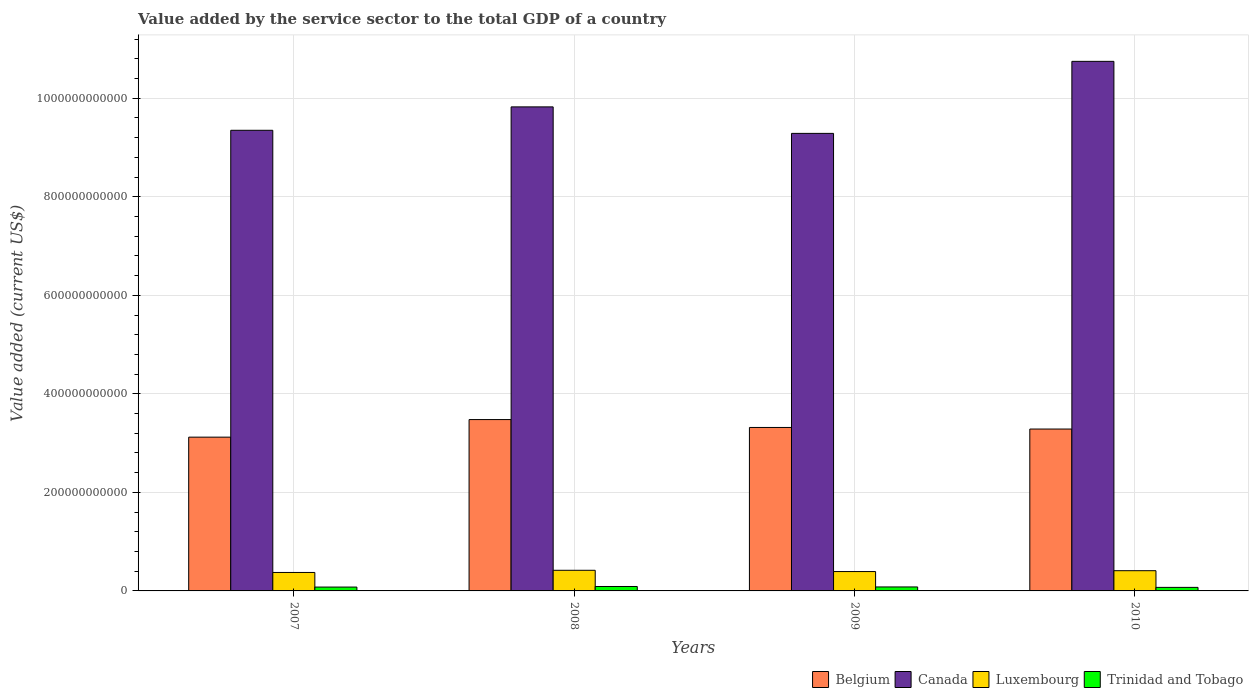How many groups of bars are there?
Your response must be concise. 4. Are the number of bars per tick equal to the number of legend labels?
Your response must be concise. Yes. Are the number of bars on each tick of the X-axis equal?
Give a very brief answer. Yes. In how many cases, is the number of bars for a given year not equal to the number of legend labels?
Make the answer very short. 0. What is the value added by the service sector to the total GDP in Belgium in 2009?
Provide a succinct answer. 3.32e+11. Across all years, what is the maximum value added by the service sector to the total GDP in Trinidad and Tobago?
Offer a terse response. 8.99e+09. Across all years, what is the minimum value added by the service sector to the total GDP in Belgium?
Offer a terse response. 3.12e+11. What is the total value added by the service sector to the total GDP in Canada in the graph?
Provide a short and direct response. 3.92e+12. What is the difference between the value added by the service sector to the total GDP in Belgium in 2007 and that in 2009?
Your answer should be very brief. -1.97e+1. What is the difference between the value added by the service sector to the total GDP in Belgium in 2008 and the value added by the service sector to the total GDP in Trinidad and Tobago in 2010?
Ensure brevity in your answer.  3.41e+11. What is the average value added by the service sector to the total GDP in Luxembourg per year?
Ensure brevity in your answer.  3.99e+1. In the year 2010, what is the difference between the value added by the service sector to the total GDP in Canada and value added by the service sector to the total GDP in Trinidad and Tobago?
Provide a short and direct response. 1.07e+12. In how many years, is the value added by the service sector to the total GDP in Luxembourg greater than 800000000000 US$?
Your response must be concise. 0. What is the ratio of the value added by the service sector to the total GDP in Belgium in 2008 to that in 2009?
Offer a very short reply. 1.05. Is the value added by the service sector to the total GDP in Trinidad and Tobago in 2007 less than that in 2008?
Your response must be concise. Yes. Is the difference between the value added by the service sector to the total GDP in Canada in 2007 and 2010 greater than the difference between the value added by the service sector to the total GDP in Trinidad and Tobago in 2007 and 2010?
Your answer should be compact. No. What is the difference between the highest and the second highest value added by the service sector to the total GDP in Luxembourg?
Your answer should be very brief. 8.35e+08. What is the difference between the highest and the lowest value added by the service sector to the total GDP in Trinidad and Tobago?
Keep it short and to the point. 1.80e+09. Is it the case that in every year, the sum of the value added by the service sector to the total GDP in Luxembourg and value added by the service sector to the total GDP in Trinidad and Tobago is greater than the sum of value added by the service sector to the total GDP in Canada and value added by the service sector to the total GDP in Belgium?
Give a very brief answer. Yes. What does the 1st bar from the left in 2008 represents?
Keep it short and to the point. Belgium. What does the 1st bar from the right in 2008 represents?
Offer a terse response. Trinidad and Tobago. How many years are there in the graph?
Offer a terse response. 4. What is the difference between two consecutive major ticks on the Y-axis?
Keep it short and to the point. 2.00e+11. Does the graph contain any zero values?
Ensure brevity in your answer.  No. Does the graph contain grids?
Ensure brevity in your answer.  Yes. Where does the legend appear in the graph?
Keep it short and to the point. Bottom right. How many legend labels are there?
Offer a terse response. 4. How are the legend labels stacked?
Ensure brevity in your answer.  Horizontal. What is the title of the graph?
Keep it short and to the point. Value added by the service sector to the total GDP of a country. Does "Central Europe" appear as one of the legend labels in the graph?
Offer a terse response. No. What is the label or title of the Y-axis?
Your response must be concise. Value added (current US$). What is the Value added (current US$) in Belgium in 2007?
Keep it short and to the point. 3.12e+11. What is the Value added (current US$) in Canada in 2007?
Offer a very short reply. 9.35e+11. What is the Value added (current US$) of Luxembourg in 2007?
Provide a short and direct response. 3.75e+1. What is the Value added (current US$) in Trinidad and Tobago in 2007?
Give a very brief answer. 7.81e+09. What is the Value added (current US$) in Belgium in 2008?
Give a very brief answer. 3.48e+11. What is the Value added (current US$) of Canada in 2008?
Keep it short and to the point. 9.82e+11. What is the Value added (current US$) in Luxembourg in 2008?
Your answer should be very brief. 4.19e+1. What is the Value added (current US$) in Trinidad and Tobago in 2008?
Provide a succinct answer. 8.99e+09. What is the Value added (current US$) of Belgium in 2009?
Offer a terse response. 3.32e+11. What is the Value added (current US$) of Canada in 2009?
Keep it short and to the point. 9.29e+11. What is the Value added (current US$) in Luxembourg in 2009?
Offer a very short reply. 3.93e+1. What is the Value added (current US$) of Trinidad and Tobago in 2009?
Make the answer very short. 8.06e+09. What is the Value added (current US$) of Belgium in 2010?
Make the answer very short. 3.29e+11. What is the Value added (current US$) of Canada in 2010?
Your answer should be very brief. 1.07e+12. What is the Value added (current US$) of Luxembourg in 2010?
Your answer should be compact. 4.10e+1. What is the Value added (current US$) of Trinidad and Tobago in 2010?
Keep it short and to the point. 7.19e+09. Across all years, what is the maximum Value added (current US$) of Belgium?
Your response must be concise. 3.48e+11. Across all years, what is the maximum Value added (current US$) in Canada?
Provide a succinct answer. 1.07e+12. Across all years, what is the maximum Value added (current US$) in Luxembourg?
Offer a very short reply. 4.19e+1. Across all years, what is the maximum Value added (current US$) in Trinidad and Tobago?
Give a very brief answer. 8.99e+09. Across all years, what is the minimum Value added (current US$) in Belgium?
Your response must be concise. 3.12e+11. Across all years, what is the minimum Value added (current US$) in Canada?
Provide a succinct answer. 9.29e+11. Across all years, what is the minimum Value added (current US$) in Luxembourg?
Make the answer very short. 3.75e+1. Across all years, what is the minimum Value added (current US$) in Trinidad and Tobago?
Provide a succinct answer. 7.19e+09. What is the total Value added (current US$) of Belgium in the graph?
Your answer should be compact. 1.32e+12. What is the total Value added (current US$) of Canada in the graph?
Keep it short and to the point. 3.92e+12. What is the total Value added (current US$) in Luxembourg in the graph?
Your answer should be compact. 1.60e+11. What is the total Value added (current US$) in Trinidad and Tobago in the graph?
Your answer should be very brief. 3.21e+1. What is the difference between the Value added (current US$) of Belgium in 2007 and that in 2008?
Provide a short and direct response. -3.57e+1. What is the difference between the Value added (current US$) in Canada in 2007 and that in 2008?
Offer a very short reply. -4.75e+1. What is the difference between the Value added (current US$) in Luxembourg in 2007 and that in 2008?
Your response must be concise. -4.41e+09. What is the difference between the Value added (current US$) of Trinidad and Tobago in 2007 and that in 2008?
Make the answer very short. -1.19e+09. What is the difference between the Value added (current US$) of Belgium in 2007 and that in 2009?
Your response must be concise. -1.97e+1. What is the difference between the Value added (current US$) in Canada in 2007 and that in 2009?
Your response must be concise. 6.28e+09. What is the difference between the Value added (current US$) in Luxembourg in 2007 and that in 2009?
Ensure brevity in your answer.  -1.84e+09. What is the difference between the Value added (current US$) of Trinidad and Tobago in 2007 and that in 2009?
Make the answer very short. -2.50e+08. What is the difference between the Value added (current US$) of Belgium in 2007 and that in 2010?
Provide a short and direct response. -1.65e+1. What is the difference between the Value added (current US$) of Canada in 2007 and that in 2010?
Ensure brevity in your answer.  -1.40e+11. What is the difference between the Value added (current US$) in Luxembourg in 2007 and that in 2010?
Make the answer very short. -3.57e+09. What is the difference between the Value added (current US$) in Trinidad and Tobago in 2007 and that in 2010?
Offer a terse response. 6.19e+08. What is the difference between the Value added (current US$) of Belgium in 2008 and that in 2009?
Provide a succinct answer. 1.60e+1. What is the difference between the Value added (current US$) in Canada in 2008 and that in 2009?
Provide a short and direct response. 5.38e+1. What is the difference between the Value added (current US$) of Luxembourg in 2008 and that in 2009?
Make the answer very short. 2.56e+09. What is the difference between the Value added (current US$) in Trinidad and Tobago in 2008 and that in 2009?
Your response must be concise. 9.36e+08. What is the difference between the Value added (current US$) of Belgium in 2008 and that in 2010?
Ensure brevity in your answer.  1.92e+1. What is the difference between the Value added (current US$) in Canada in 2008 and that in 2010?
Ensure brevity in your answer.  -9.24e+1. What is the difference between the Value added (current US$) of Luxembourg in 2008 and that in 2010?
Keep it short and to the point. 8.35e+08. What is the difference between the Value added (current US$) in Trinidad and Tobago in 2008 and that in 2010?
Offer a very short reply. 1.80e+09. What is the difference between the Value added (current US$) of Belgium in 2009 and that in 2010?
Your answer should be compact. 3.19e+09. What is the difference between the Value added (current US$) of Canada in 2009 and that in 2010?
Keep it short and to the point. -1.46e+11. What is the difference between the Value added (current US$) of Luxembourg in 2009 and that in 2010?
Make the answer very short. -1.73e+09. What is the difference between the Value added (current US$) of Trinidad and Tobago in 2009 and that in 2010?
Keep it short and to the point. 8.68e+08. What is the difference between the Value added (current US$) of Belgium in 2007 and the Value added (current US$) of Canada in 2008?
Offer a very short reply. -6.70e+11. What is the difference between the Value added (current US$) in Belgium in 2007 and the Value added (current US$) in Luxembourg in 2008?
Give a very brief answer. 2.70e+11. What is the difference between the Value added (current US$) of Belgium in 2007 and the Value added (current US$) of Trinidad and Tobago in 2008?
Make the answer very short. 3.03e+11. What is the difference between the Value added (current US$) of Canada in 2007 and the Value added (current US$) of Luxembourg in 2008?
Keep it short and to the point. 8.93e+11. What is the difference between the Value added (current US$) of Canada in 2007 and the Value added (current US$) of Trinidad and Tobago in 2008?
Your response must be concise. 9.26e+11. What is the difference between the Value added (current US$) in Luxembourg in 2007 and the Value added (current US$) in Trinidad and Tobago in 2008?
Your response must be concise. 2.85e+1. What is the difference between the Value added (current US$) in Belgium in 2007 and the Value added (current US$) in Canada in 2009?
Offer a very short reply. -6.17e+11. What is the difference between the Value added (current US$) in Belgium in 2007 and the Value added (current US$) in Luxembourg in 2009?
Offer a terse response. 2.73e+11. What is the difference between the Value added (current US$) in Belgium in 2007 and the Value added (current US$) in Trinidad and Tobago in 2009?
Keep it short and to the point. 3.04e+11. What is the difference between the Value added (current US$) of Canada in 2007 and the Value added (current US$) of Luxembourg in 2009?
Your response must be concise. 8.96e+11. What is the difference between the Value added (current US$) in Canada in 2007 and the Value added (current US$) in Trinidad and Tobago in 2009?
Offer a terse response. 9.27e+11. What is the difference between the Value added (current US$) in Luxembourg in 2007 and the Value added (current US$) in Trinidad and Tobago in 2009?
Provide a succinct answer. 2.94e+1. What is the difference between the Value added (current US$) of Belgium in 2007 and the Value added (current US$) of Canada in 2010?
Offer a terse response. -7.63e+11. What is the difference between the Value added (current US$) of Belgium in 2007 and the Value added (current US$) of Luxembourg in 2010?
Your answer should be very brief. 2.71e+11. What is the difference between the Value added (current US$) of Belgium in 2007 and the Value added (current US$) of Trinidad and Tobago in 2010?
Offer a very short reply. 3.05e+11. What is the difference between the Value added (current US$) in Canada in 2007 and the Value added (current US$) in Luxembourg in 2010?
Provide a succinct answer. 8.94e+11. What is the difference between the Value added (current US$) of Canada in 2007 and the Value added (current US$) of Trinidad and Tobago in 2010?
Your answer should be very brief. 9.28e+11. What is the difference between the Value added (current US$) of Luxembourg in 2007 and the Value added (current US$) of Trinidad and Tobago in 2010?
Ensure brevity in your answer.  3.03e+1. What is the difference between the Value added (current US$) of Belgium in 2008 and the Value added (current US$) of Canada in 2009?
Your answer should be very brief. -5.81e+11. What is the difference between the Value added (current US$) in Belgium in 2008 and the Value added (current US$) in Luxembourg in 2009?
Your answer should be compact. 3.08e+11. What is the difference between the Value added (current US$) in Belgium in 2008 and the Value added (current US$) in Trinidad and Tobago in 2009?
Make the answer very short. 3.40e+11. What is the difference between the Value added (current US$) in Canada in 2008 and the Value added (current US$) in Luxembourg in 2009?
Your response must be concise. 9.43e+11. What is the difference between the Value added (current US$) of Canada in 2008 and the Value added (current US$) of Trinidad and Tobago in 2009?
Offer a terse response. 9.74e+11. What is the difference between the Value added (current US$) of Luxembourg in 2008 and the Value added (current US$) of Trinidad and Tobago in 2009?
Offer a terse response. 3.38e+1. What is the difference between the Value added (current US$) in Belgium in 2008 and the Value added (current US$) in Canada in 2010?
Give a very brief answer. -7.27e+11. What is the difference between the Value added (current US$) in Belgium in 2008 and the Value added (current US$) in Luxembourg in 2010?
Your answer should be very brief. 3.07e+11. What is the difference between the Value added (current US$) of Belgium in 2008 and the Value added (current US$) of Trinidad and Tobago in 2010?
Your response must be concise. 3.41e+11. What is the difference between the Value added (current US$) in Canada in 2008 and the Value added (current US$) in Luxembourg in 2010?
Your answer should be compact. 9.41e+11. What is the difference between the Value added (current US$) in Canada in 2008 and the Value added (current US$) in Trinidad and Tobago in 2010?
Keep it short and to the point. 9.75e+11. What is the difference between the Value added (current US$) in Luxembourg in 2008 and the Value added (current US$) in Trinidad and Tobago in 2010?
Your answer should be compact. 3.47e+1. What is the difference between the Value added (current US$) of Belgium in 2009 and the Value added (current US$) of Canada in 2010?
Offer a very short reply. -7.43e+11. What is the difference between the Value added (current US$) of Belgium in 2009 and the Value added (current US$) of Luxembourg in 2010?
Your answer should be compact. 2.91e+11. What is the difference between the Value added (current US$) in Belgium in 2009 and the Value added (current US$) in Trinidad and Tobago in 2010?
Your answer should be very brief. 3.25e+11. What is the difference between the Value added (current US$) of Canada in 2009 and the Value added (current US$) of Luxembourg in 2010?
Your answer should be very brief. 8.88e+11. What is the difference between the Value added (current US$) in Canada in 2009 and the Value added (current US$) in Trinidad and Tobago in 2010?
Give a very brief answer. 9.21e+11. What is the difference between the Value added (current US$) of Luxembourg in 2009 and the Value added (current US$) of Trinidad and Tobago in 2010?
Your response must be concise. 3.21e+1. What is the average Value added (current US$) in Belgium per year?
Offer a very short reply. 3.30e+11. What is the average Value added (current US$) in Canada per year?
Your answer should be very brief. 9.80e+11. What is the average Value added (current US$) of Luxembourg per year?
Give a very brief answer. 3.99e+1. What is the average Value added (current US$) of Trinidad and Tobago per year?
Your response must be concise. 8.01e+09. In the year 2007, what is the difference between the Value added (current US$) of Belgium and Value added (current US$) of Canada?
Your answer should be very brief. -6.23e+11. In the year 2007, what is the difference between the Value added (current US$) of Belgium and Value added (current US$) of Luxembourg?
Provide a succinct answer. 2.75e+11. In the year 2007, what is the difference between the Value added (current US$) in Belgium and Value added (current US$) in Trinidad and Tobago?
Provide a succinct answer. 3.04e+11. In the year 2007, what is the difference between the Value added (current US$) in Canada and Value added (current US$) in Luxembourg?
Offer a very short reply. 8.97e+11. In the year 2007, what is the difference between the Value added (current US$) of Canada and Value added (current US$) of Trinidad and Tobago?
Your answer should be very brief. 9.27e+11. In the year 2007, what is the difference between the Value added (current US$) in Luxembourg and Value added (current US$) in Trinidad and Tobago?
Make the answer very short. 2.97e+1. In the year 2008, what is the difference between the Value added (current US$) in Belgium and Value added (current US$) in Canada?
Provide a succinct answer. -6.35e+11. In the year 2008, what is the difference between the Value added (current US$) in Belgium and Value added (current US$) in Luxembourg?
Give a very brief answer. 3.06e+11. In the year 2008, what is the difference between the Value added (current US$) of Belgium and Value added (current US$) of Trinidad and Tobago?
Give a very brief answer. 3.39e+11. In the year 2008, what is the difference between the Value added (current US$) in Canada and Value added (current US$) in Luxembourg?
Provide a succinct answer. 9.41e+11. In the year 2008, what is the difference between the Value added (current US$) of Canada and Value added (current US$) of Trinidad and Tobago?
Provide a short and direct response. 9.73e+11. In the year 2008, what is the difference between the Value added (current US$) in Luxembourg and Value added (current US$) in Trinidad and Tobago?
Give a very brief answer. 3.29e+1. In the year 2009, what is the difference between the Value added (current US$) in Belgium and Value added (current US$) in Canada?
Keep it short and to the point. -5.97e+11. In the year 2009, what is the difference between the Value added (current US$) in Belgium and Value added (current US$) in Luxembourg?
Your answer should be very brief. 2.92e+11. In the year 2009, what is the difference between the Value added (current US$) of Belgium and Value added (current US$) of Trinidad and Tobago?
Make the answer very short. 3.24e+11. In the year 2009, what is the difference between the Value added (current US$) in Canada and Value added (current US$) in Luxembourg?
Make the answer very short. 8.89e+11. In the year 2009, what is the difference between the Value added (current US$) of Canada and Value added (current US$) of Trinidad and Tobago?
Offer a very short reply. 9.21e+11. In the year 2009, what is the difference between the Value added (current US$) in Luxembourg and Value added (current US$) in Trinidad and Tobago?
Keep it short and to the point. 3.13e+1. In the year 2010, what is the difference between the Value added (current US$) of Belgium and Value added (current US$) of Canada?
Make the answer very short. -7.46e+11. In the year 2010, what is the difference between the Value added (current US$) in Belgium and Value added (current US$) in Luxembourg?
Keep it short and to the point. 2.88e+11. In the year 2010, what is the difference between the Value added (current US$) of Belgium and Value added (current US$) of Trinidad and Tobago?
Give a very brief answer. 3.21e+11. In the year 2010, what is the difference between the Value added (current US$) in Canada and Value added (current US$) in Luxembourg?
Offer a terse response. 1.03e+12. In the year 2010, what is the difference between the Value added (current US$) in Canada and Value added (current US$) in Trinidad and Tobago?
Offer a terse response. 1.07e+12. In the year 2010, what is the difference between the Value added (current US$) in Luxembourg and Value added (current US$) in Trinidad and Tobago?
Offer a very short reply. 3.38e+1. What is the ratio of the Value added (current US$) of Belgium in 2007 to that in 2008?
Provide a succinct answer. 0.9. What is the ratio of the Value added (current US$) in Canada in 2007 to that in 2008?
Keep it short and to the point. 0.95. What is the ratio of the Value added (current US$) of Luxembourg in 2007 to that in 2008?
Provide a succinct answer. 0.89. What is the ratio of the Value added (current US$) in Trinidad and Tobago in 2007 to that in 2008?
Your answer should be very brief. 0.87. What is the ratio of the Value added (current US$) in Belgium in 2007 to that in 2009?
Your response must be concise. 0.94. What is the ratio of the Value added (current US$) in Canada in 2007 to that in 2009?
Your answer should be compact. 1.01. What is the ratio of the Value added (current US$) of Luxembourg in 2007 to that in 2009?
Ensure brevity in your answer.  0.95. What is the ratio of the Value added (current US$) of Belgium in 2007 to that in 2010?
Offer a terse response. 0.95. What is the ratio of the Value added (current US$) of Canada in 2007 to that in 2010?
Offer a very short reply. 0.87. What is the ratio of the Value added (current US$) of Trinidad and Tobago in 2007 to that in 2010?
Make the answer very short. 1.09. What is the ratio of the Value added (current US$) of Belgium in 2008 to that in 2009?
Offer a very short reply. 1.05. What is the ratio of the Value added (current US$) of Canada in 2008 to that in 2009?
Your answer should be very brief. 1.06. What is the ratio of the Value added (current US$) of Luxembourg in 2008 to that in 2009?
Provide a succinct answer. 1.07. What is the ratio of the Value added (current US$) in Trinidad and Tobago in 2008 to that in 2009?
Provide a succinct answer. 1.12. What is the ratio of the Value added (current US$) in Belgium in 2008 to that in 2010?
Provide a succinct answer. 1.06. What is the ratio of the Value added (current US$) of Canada in 2008 to that in 2010?
Give a very brief answer. 0.91. What is the ratio of the Value added (current US$) of Luxembourg in 2008 to that in 2010?
Provide a short and direct response. 1.02. What is the ratio of the Value added (current US$) of Trinidad and Tobago in 2008 to that in 2010?
Your response must be concise. 1.25. What is the ratio of the Value added (current US$) in Belgium in 2009 to that in 2010?
Give a very brief answer. 1.01. What is the ratio of the Value added (current US$) in Canada in 2009 to that in 2010?
Offer a terse response. 0.86. What is the ratio of the Value added (current US$) in Luxembourg in 2009 to that in 2010?
Offer a terse response. 0.96. What is the ratio of the Value added (current US$) of Trinidad and Tobago in 2009 to that in 2010?
Your response must be concise. 1.12. What is the difference between the highest and the second highest Value added (current US$) of Belgium?
Your answer should be compact. 1.60e+1. What is the difference between the highest and the second highest Value added (current US$) in Canada?
Ensure brevity in your answer.  9.24e+1. What is the difference between the highest and the second highest Value added (current US$) of Luxembourg?
Offer a very short reply. 8.35e+08. What is the difference between the highest and the second highest Value added (current US$) in Trinidad and Tobago?
Provide a short and direct response. 9.36e+08. What is the difference between the highest and the lowest Value added (current US$) in Belgium?
Make the answer very short. 3.57e+1. What is the difference between the highest and the lowest Value added (current US$) in Canada?
Your answer should be compact. 1.46e+11. What is the difference between the highest and the lowest Value added (current US$) of Luxembourg?
Ensure brevity in your answer.  4.41e+09. What is the difference between the highest and the lowest Value added (current US$) in Trinidad and Tobago?
Provide a short and direct response. 1.80e+09. 